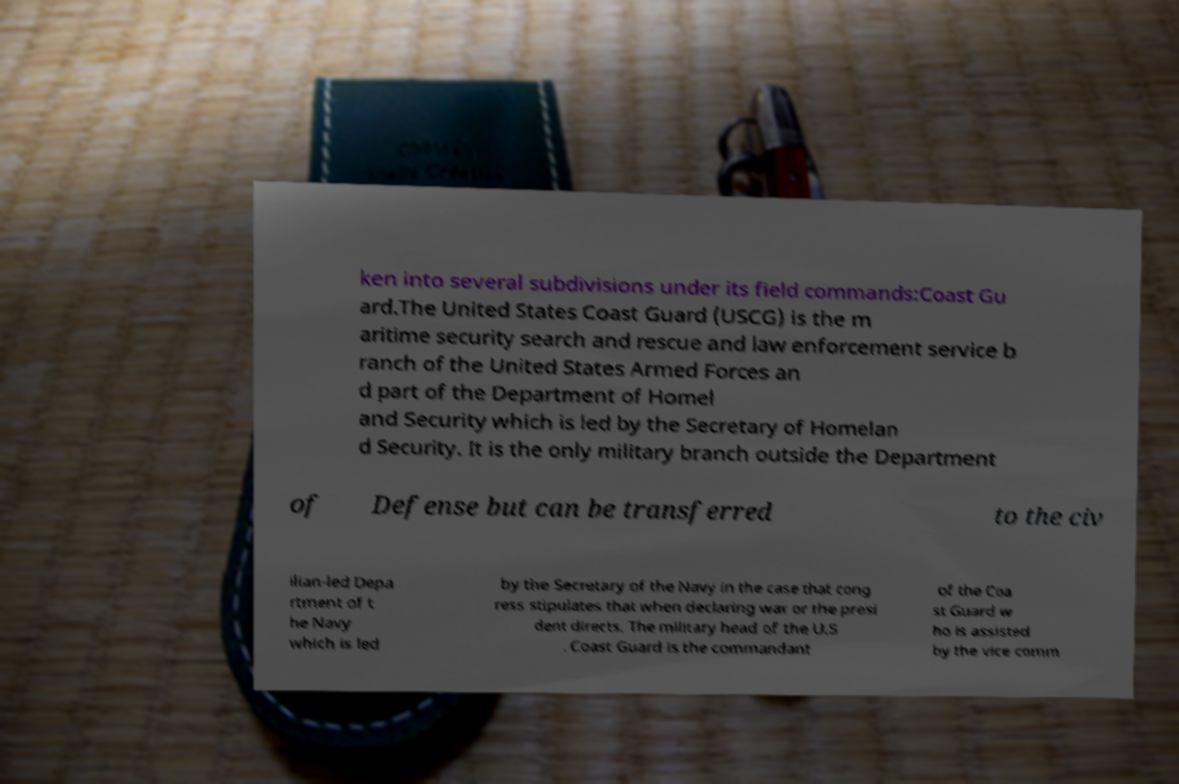There's text embedded in this image that I need extracted. Can you transcribe it verbatim? ken into several subdivisions under its field commands:Coast Gu ard.The United States Coast Guard (USCG) is the m aritime security search and rescue and law enforcement service b ranch of the United States Armed Forces an d part of the Department of Homel and Security which is led by the Secretary of Homelan d Security. It is the only military branch outside the Department of Defense but can be transferred to the civ ilian-led Depa rtment of t he Navy which is led by the Secretary of the Navy in the case that cong ress stipulates that when declaring war or the presi dent directs. The military head of the U.S . Coast Guard is the commandant of the Coa st Guard w ho is assisted by the vice comm 